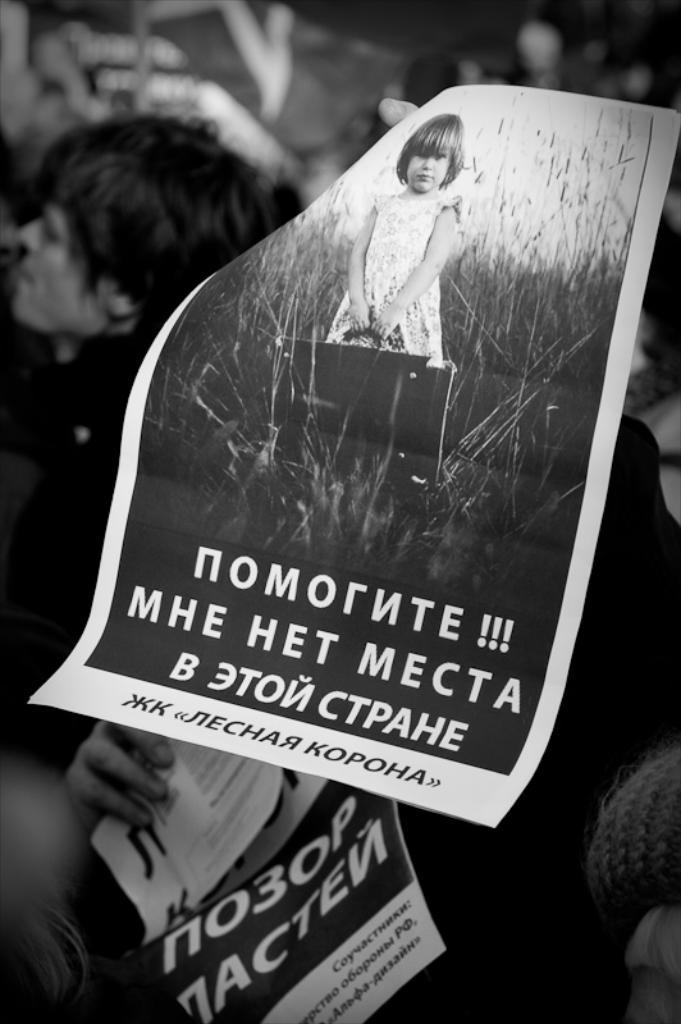What can be seen hanging on the walls in the image? There are posters in the image. Who or what is present in the image? There are people in the image. Can you describe the background of the image? The background of the image is blurry. Can you tell me how many members are in the band that is performing in the image? There is no band present in the image; it only features posters and people. What type of agreement is being signed by the people in the image? There is no agreement being signed in the image; it only shows posters and people. 